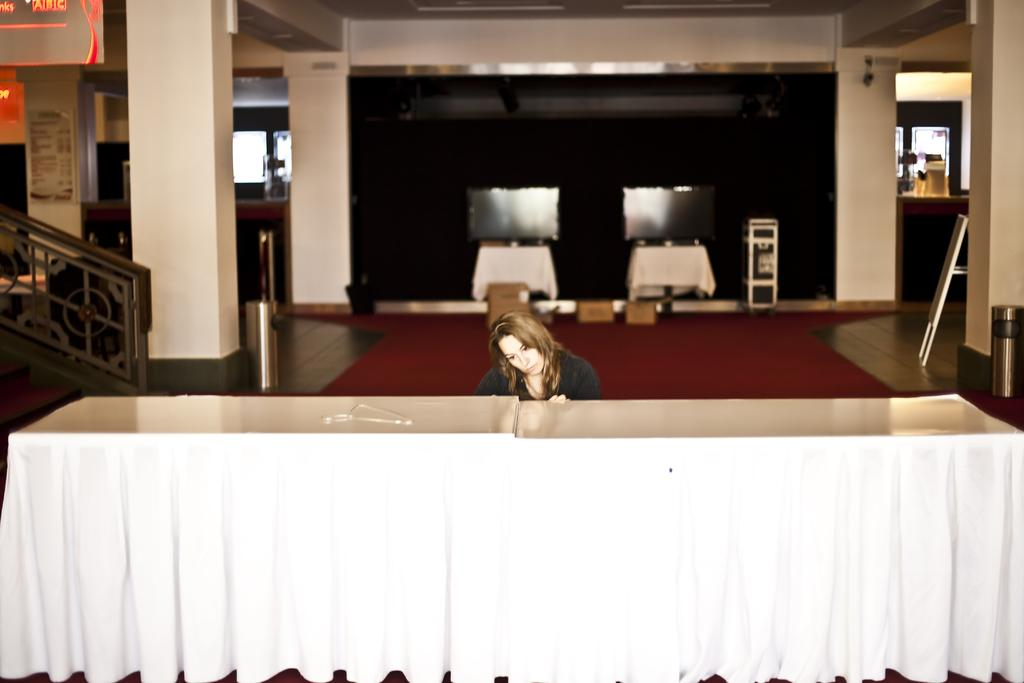Who is the main subject in the image? There is a woman in the image. What is the woman standing in front of? The woman is in front of a table. What type of flooring is visible in the image? There is a red carpet on the floor in the image. What type of chair is present in the image? There is no chair present in the image. Can you provide an example of a zoo animal that might be found in the image? There are no animals, including zoo animals, present in the image. 